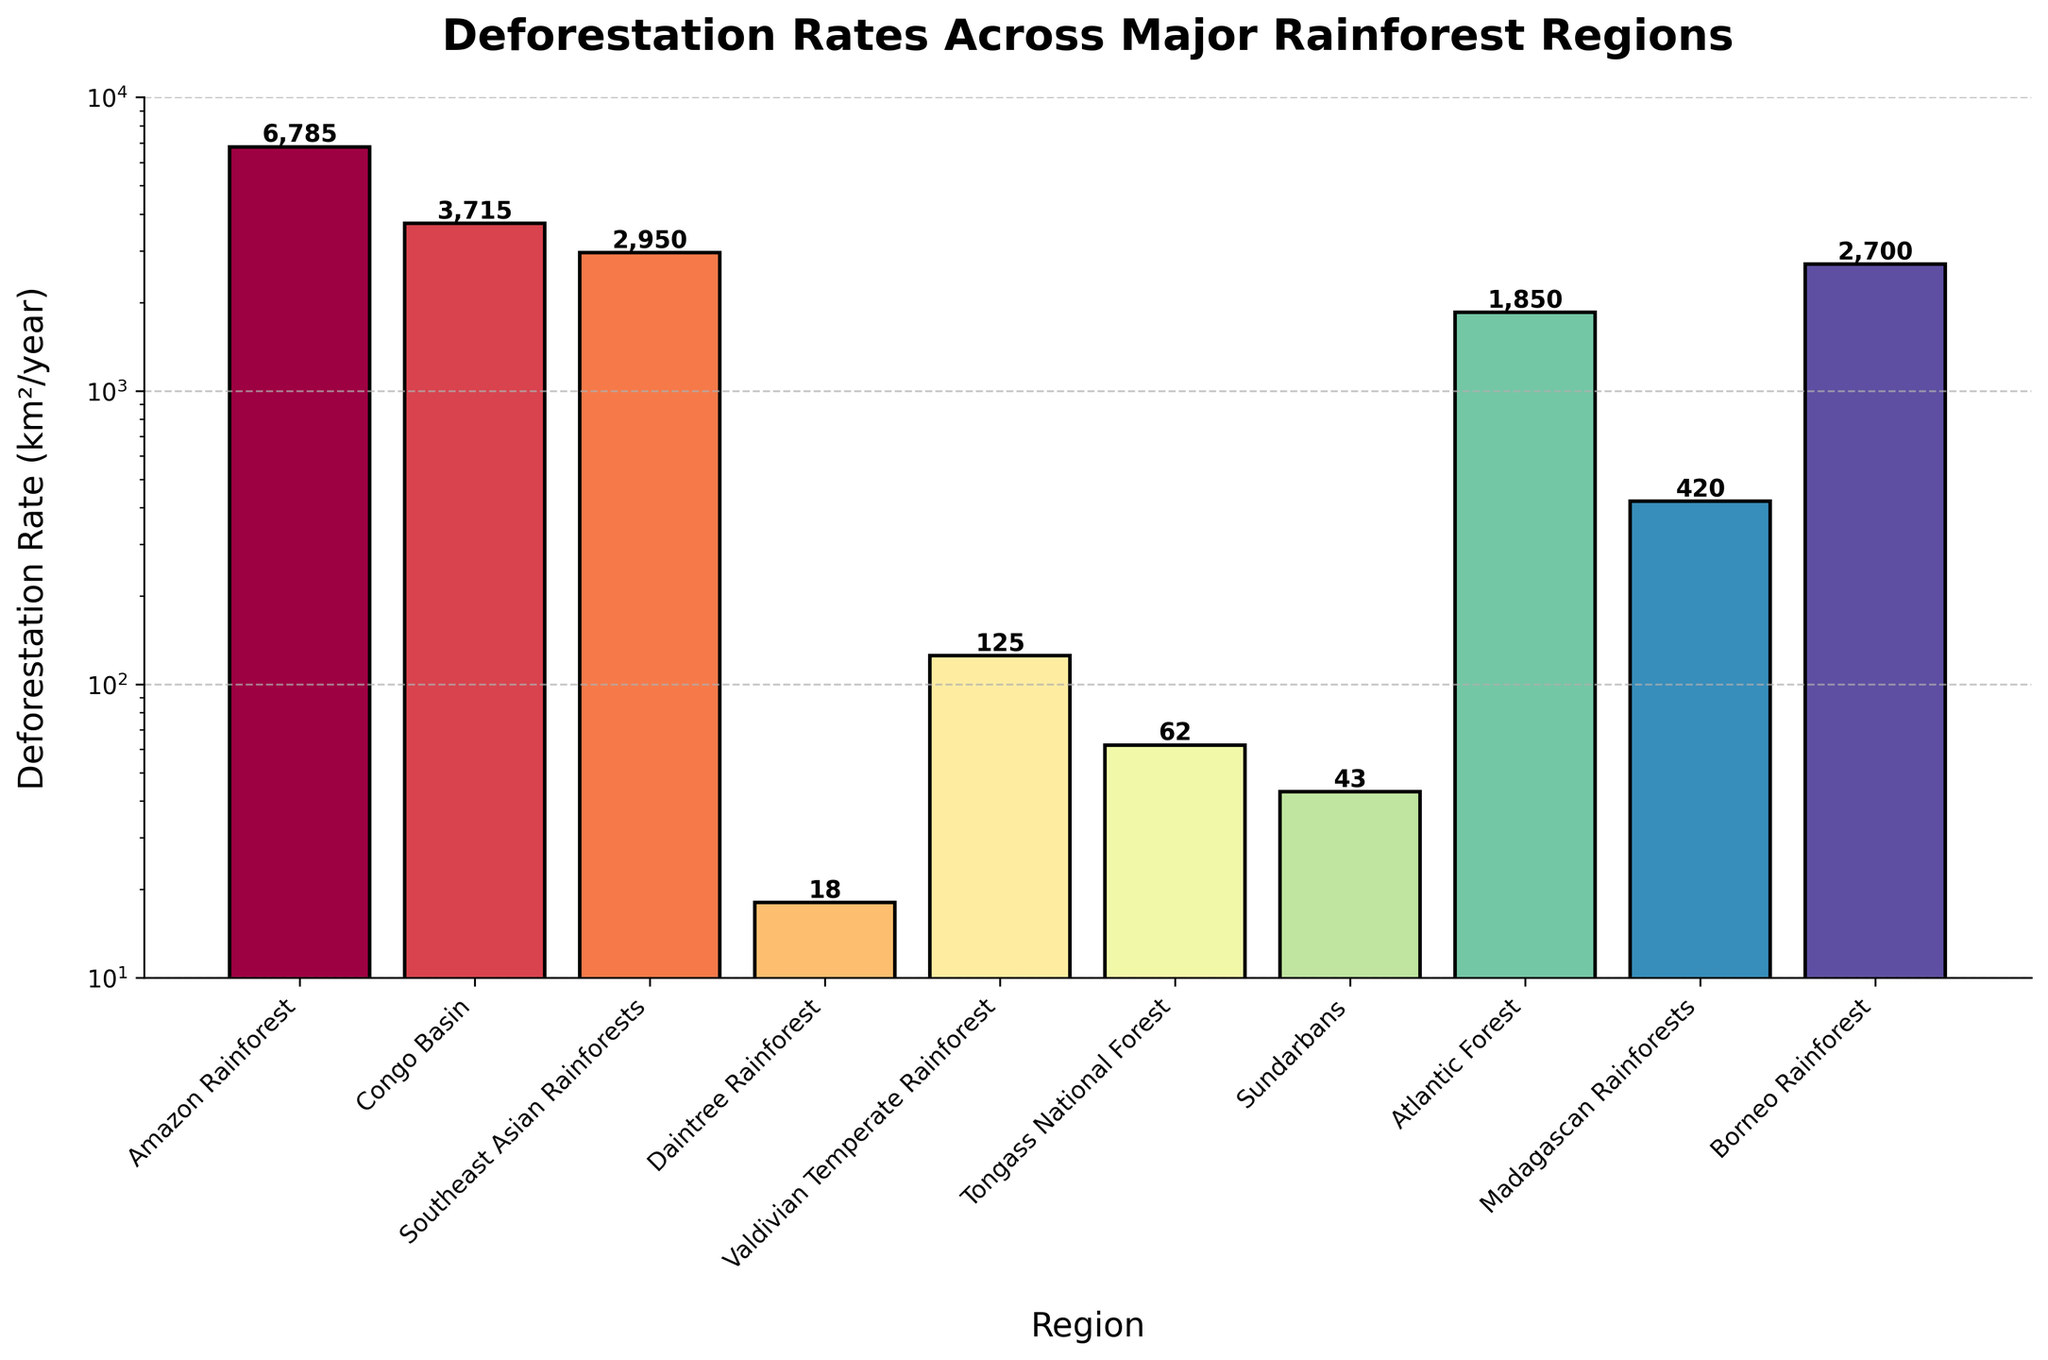What's the region with the highest deforestation rate? The region with the highest bar height represents the highest deforestation rate. In the figure, the Amazon Rainforest has the tallest bar.
Answer: Amazon Rainforest Which rainforest has the lowest deforestation rate? The region with the shortest bar represents the lowest deforestation rate. In the figure, the Daintree Rainforest has the shortest bar.
Answer: Daintree Rainforest What is the approximate deforestation rate of the Atlantic Forest? The height of the corresponding bar provides the deforestation rate. The bar for the Atlantic Forest is labeled as 1850 km²/year.
Answer: 1850 km²/year How does the deforestation rate of the Congo Basin compare to that of the Southeast Asian Rainforests? Compare the heights of the bars for the Congo Basin and Southeast Asian Rainforests. The Congo Basin's bar is taller, indicating a higher deforestation rate.
Answer: Congo Basin has a higher rate By how much does the deforestation rate of the Amazon Rainforest exceed that of the Borneo Rainforest? Subtract the deforestation rate of the Borneo Rainforest from that of the Amazon Rainforest. The rates are 6785 km²/year (Amazon) and 2700 km²/year (Borneo). 6785 - 2700 = 4085 km²/year.
Answer: 4085 km²/year What is the combined deforestation rate of the Amazon Rainforest and the Congo Basin? Add the deforestation rates of the Amazon Rainforest and the Congo Basin. The rates are 6785 km²/year and 3715 km²/year, respectively. 6785 + 3715 = 10500 km²/year.
Answer: 10500 km²/year Which regions have deforestation rates under 100 km²/year? Identify the regions with shorter bars under the 100 km²/year mark: Daintree Rainforest, Tongass National Forest, and Sundarbans.
Answer: Daintree Rainforest, Tongass National Forest, Sundarbans What is the total deforestation rate of all listed regions? Sum the deforestation rates of all regions: 6785 + 3715 + 2950 + 18 + 125 + 62 + 43 + 1850 + 420 + 2700 = 18968 km²/year.
Answer: 18968 km²/year In terms of visual length, how much taller is the bar for the Amazon Rainforest compared to the Tongass National Forest? The Amazon Rainforest's bar is significantly taller than the Tongass National Forest's bar. Eyeball the approximate relative difference visually. The Amazon bar is about 6785 km²/year whereas Tongass is 62 km²/year, making Amazon's bar roughly 109 times taller.
Answer: Approximately 109 times taller 